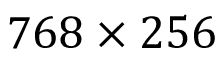Convert formula to latex. <formula><loc_0><loc_0><loc_500><loc_500>7 6 8 \times 2 5 6</formula> 